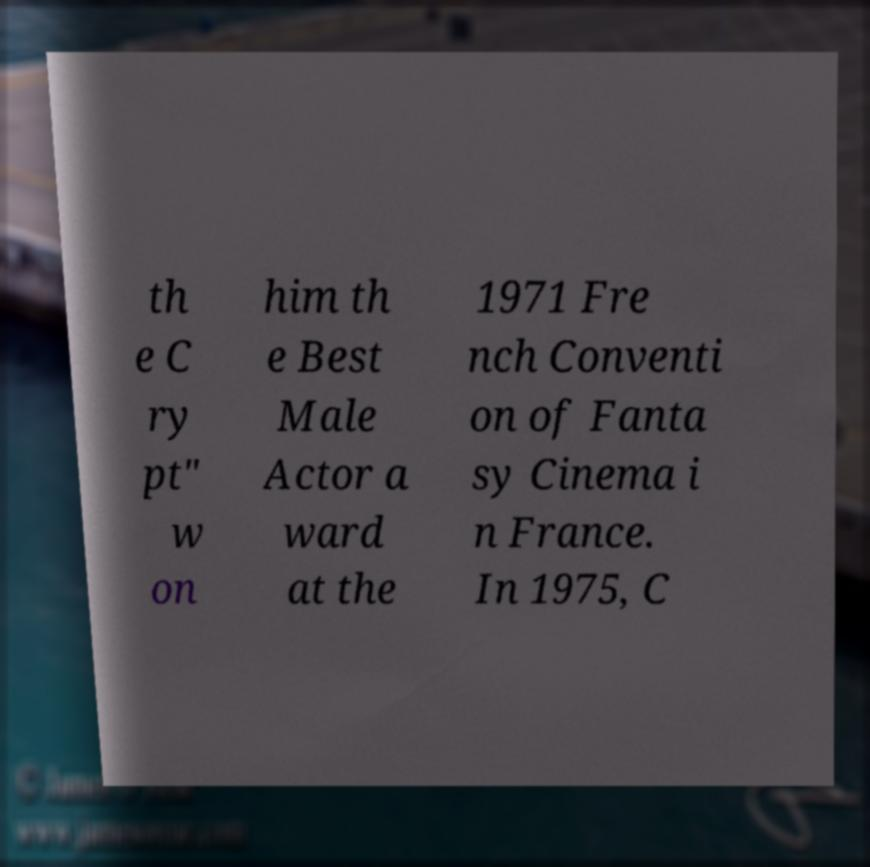There's text embedded in this image that I need extracted. Can you transcribe it verbatim? th e C ry pt" w on him th e Best Male Actor a ward at the 1971 Fre nch Conventi on of Fanta sy Cinema i n France. In 1975, C 